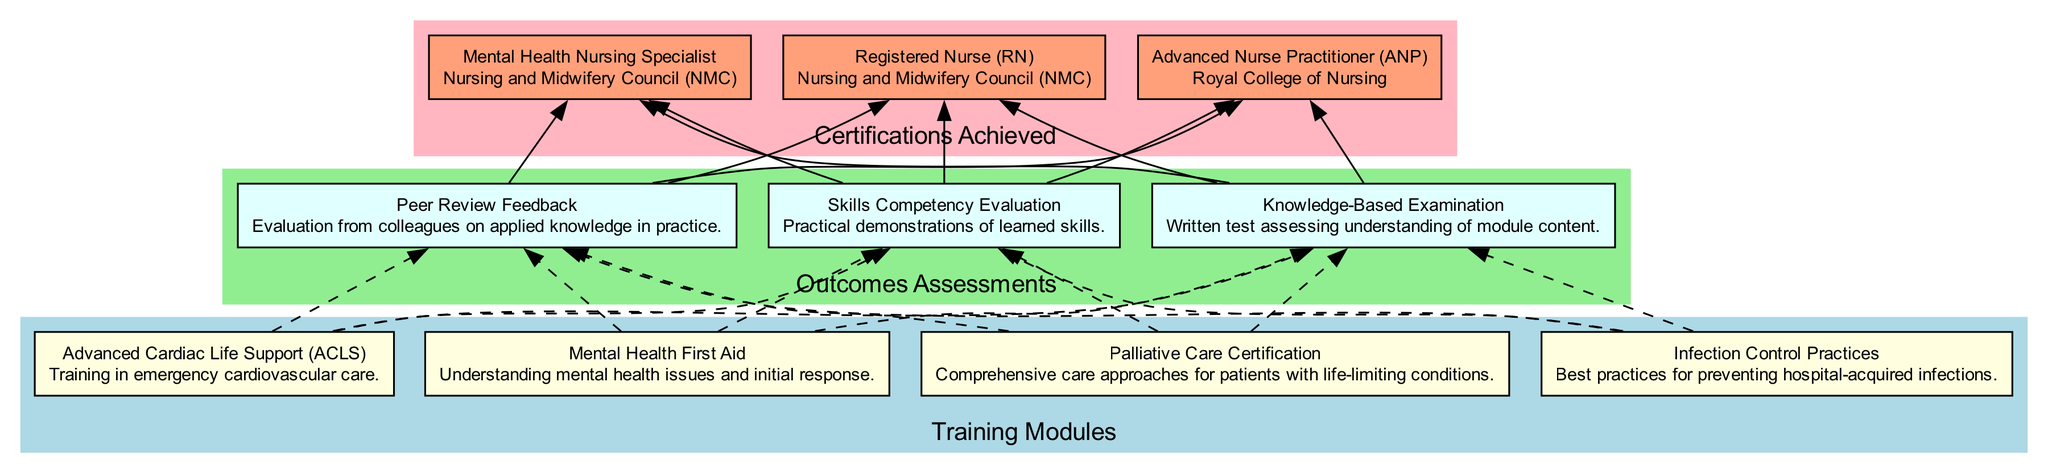What are the names of the training modules? The training modules in the diagram include "Advanced Cardiac Life Support (ACLS)", "Mental Health First Aid", "Palliative Care Certification", and "Infection Control Practices".
Answer: Advanced Cardiac Life Support (ACLS), Mental Health First Aid, Palliative Care Certification, Infection Control Practices How many outcomes assessments are listed in the diagram? The diagram contains three outcomes assessments: "Skills Competency Evaluation", "Knowledge-Based Examination", and "Peer Review Feedback". Thus, the total count is three.
Answer: 3 Which certification is issued by the Nursing and Midwifery Council? The certifications in the diagram that are issued by the Nursing and Midwifery Council are "Registered Nurse (RN)" and "Mental Health Nursing Specialist".
Answer: Registered Nurse (RN), Mental Health Nursing Specialist What is the relationship between the "Advanced Cardiac Life Support (ACLS)" module and the outcomes assessments? The "Advanced Cardiac Life Support (ACLS)" module connects to each of the outcomes assessments through dashed edges in the diagram, indicating that evaluations will follow the training module.
Answer: Skills Competency Evaluation, Knowledge-Based Examination, Peer Review Feedback Which outcomes assessment directly leads to achieving a certification? The "Knowledge-Based Examination" directly leads to achieving a certification, evidenced by the dashed connection in the diagram to the certification nodes.
Answer: Knowledge-Based Examination How many certifications are achieved in total? The diagram lists three certifications achieved: "Registered Nurse (RN)", "Advanced Nurse Practitioner (ANP)", and "Mental Health Nursing Specialist". Therefore, the total count of certifications is three.
Answer: 3 What color represents the "Certifications Achieved" section in the diagram? The "Certifications Achieved" section is represented in light pink according to the color coding used for the different sections in the diagram.
Answer: Light pink Which module covers emergency cardiovascular care? The module that covers emergency cardiovascular care is "Advanced Cardiac Life Support (ACLS)", as mentioned in its description in the diagram.
Answer: Advanced Cardiac Life Support (ACLS) What type of assessment involves practical demonstrations? "Skills Competency Evaluation" involves practical demonstrations of learned skills, making it the assessment type associated with that evaluation method.
Answer: Skills Competency Evaluation 